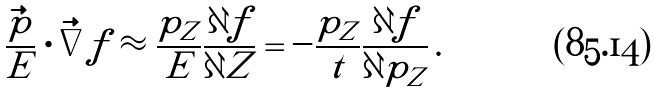<formula> <loc_0><loc_0><loc_500><loc_500>\frac { \vec { p } } { E } \cdot \vec { \nabla } f \approx \frac { p _ { Z } } { E } \frac { \partial f } { \partial Z } = - \frac { p _ { Z } } { t } \frac { \partial f } { \partial p _ { Z } } \, .</formula> 